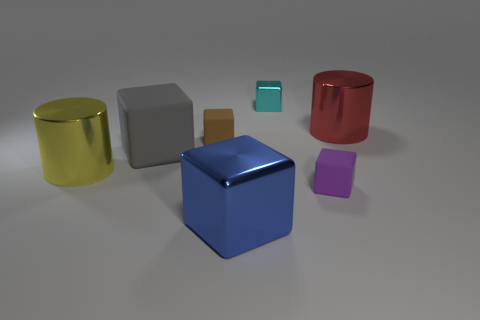Subtract all large metallic cubes. How many cubes are left? 4 Add 1 gray shiny blocks. How many objects exist? 8 Subtract all blocks. How many objects are left? 2 Subtract 4 cubes. How many cubes are left? 1 Subtract all brown cubes. How many cubes are left? 4 Subtract all small red metal balls. Subtract all small metal things. How many objects are left? 6 Add 6 yellow metallic cylinders. How many yellow metallic cylinders are left? 7 Add 6 tiny blue rubber spheres. How many tiny blue rubber spheres exist? 6 Subtract 1 red cylinders. How many objects are left? 6 Subtract all yellow blocks. Subtract all green balls. How many blocks are left? 5 